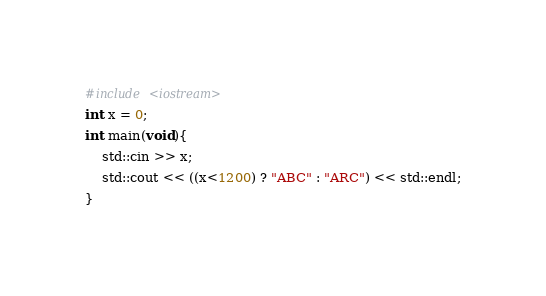Convert code to text. <code><loc_0><loc_0><loc_500><loc_500><_C++_>#include <iostream>
int x = 0;
int main(void){
    std::cin >> x;
    std::cout << ((x<1200) ? "ABC" : "ARC") << std::endl;
}
</code> 